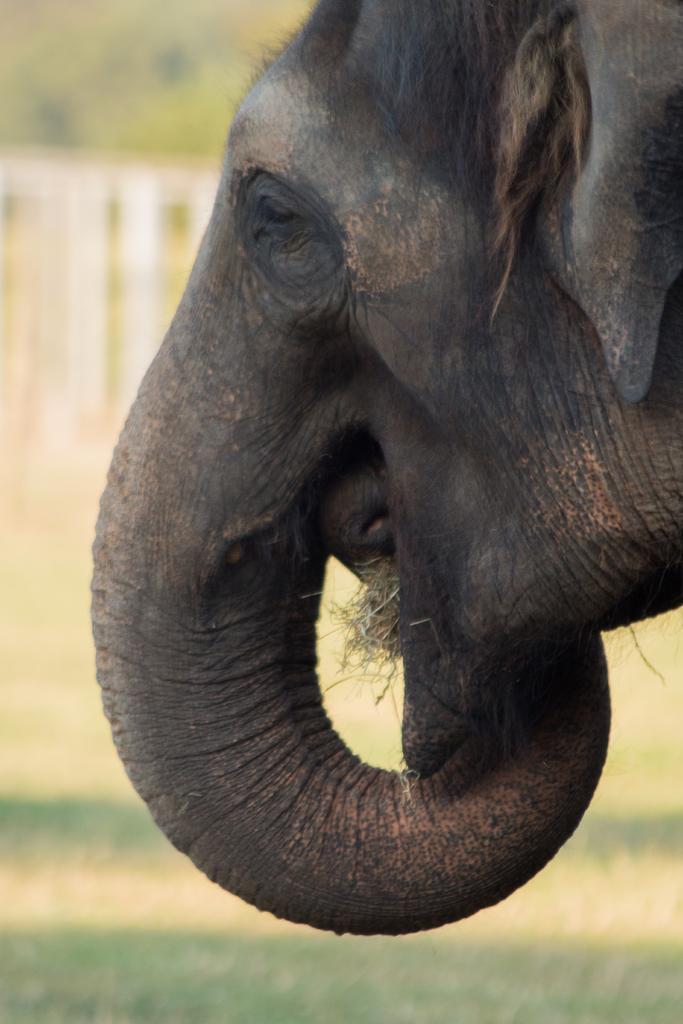Could you give a brief overview of what you see in this image? In the image there is an elephant, only the head part of the elephant is visible in the image, the background of the elephant is blur. 